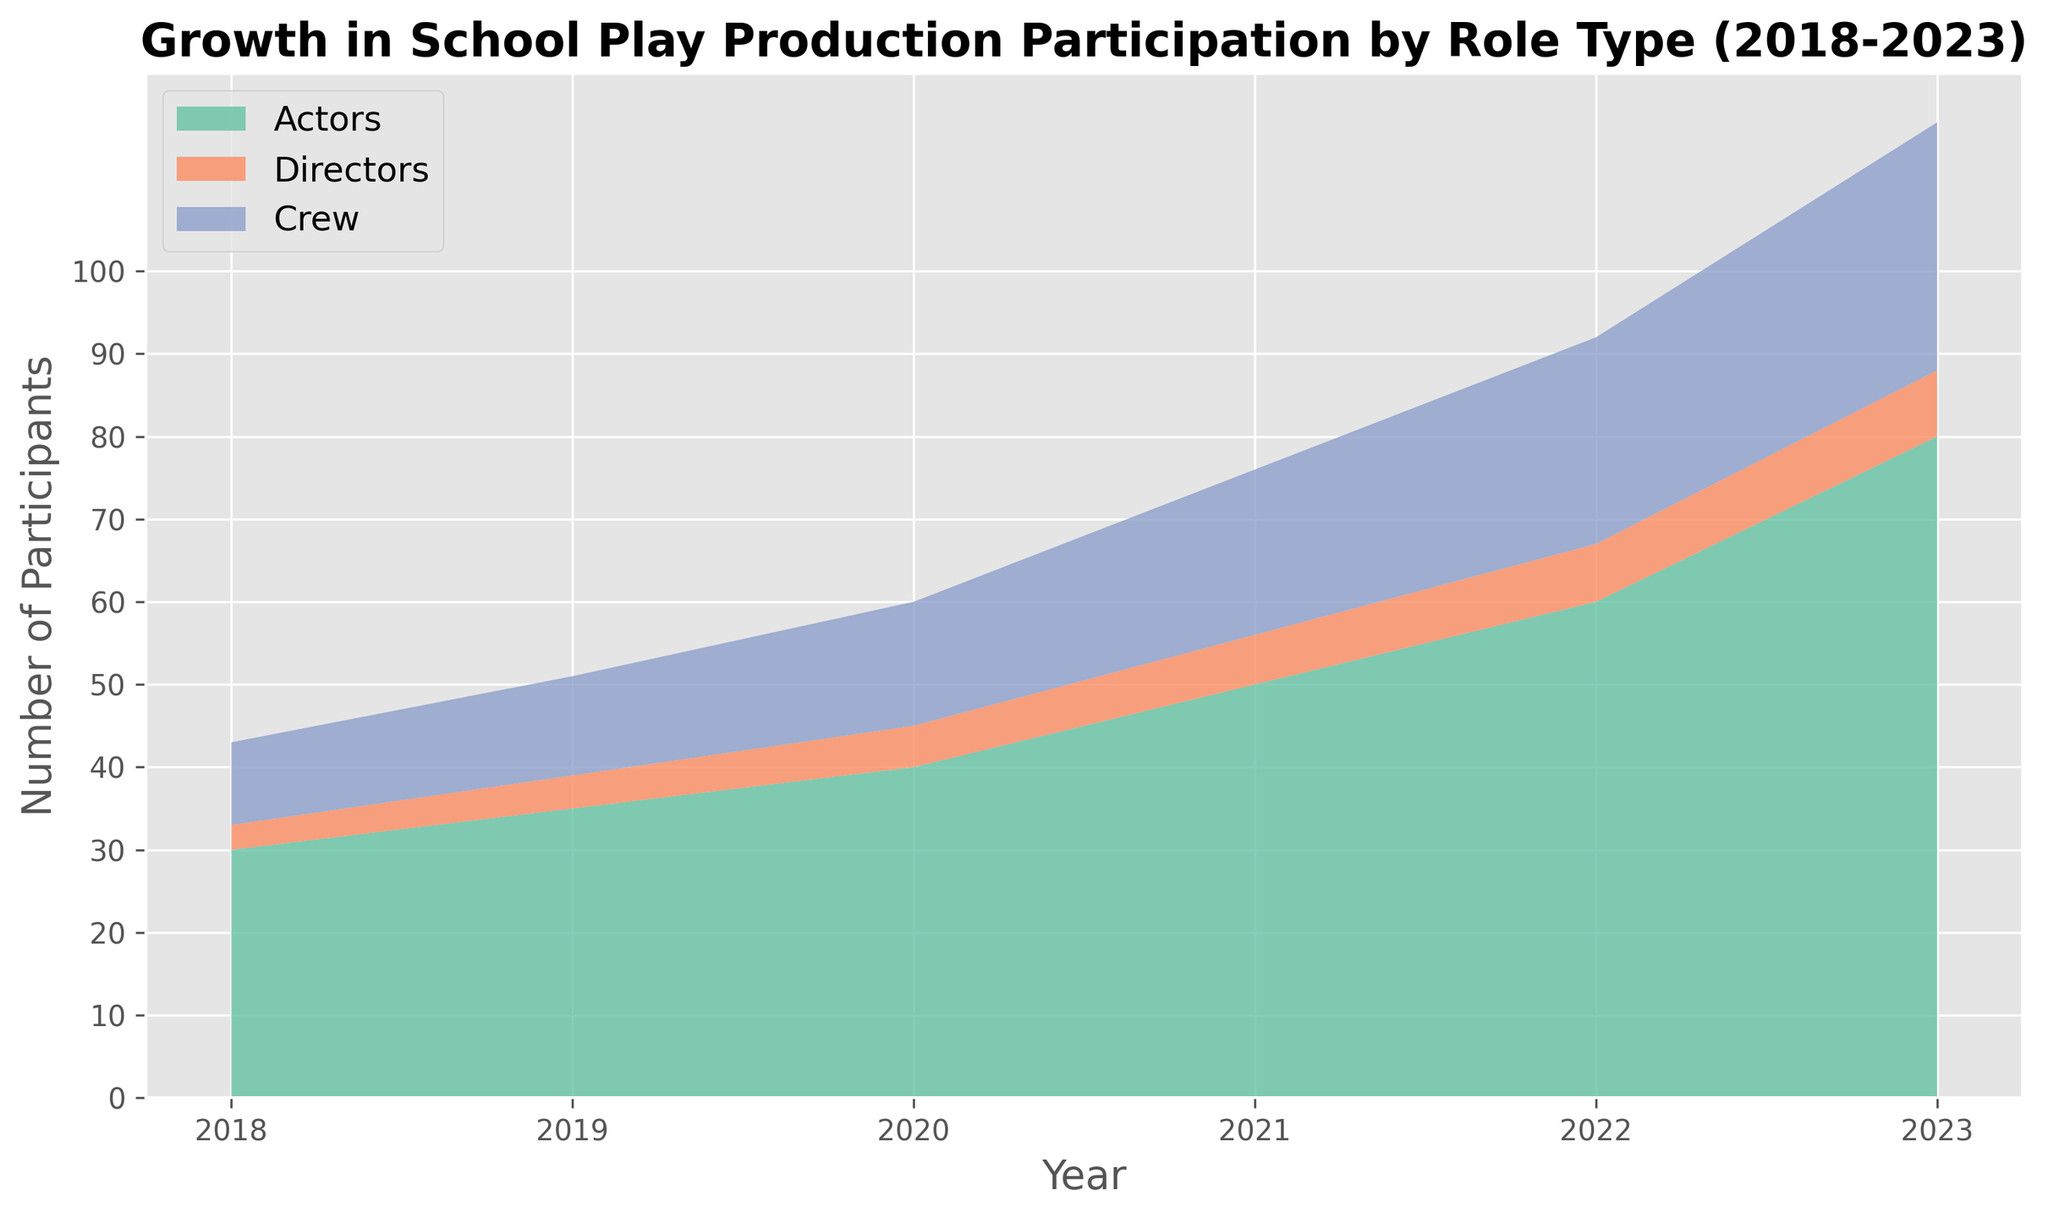Which role type had the highest participation in 2023? Observe the values for each role type in 2023. Actors had 80 participants, Directors had 8, and Crew had 30. Hence, Actors had the highest participation.
Answer: Actors In which year did the Crew first exceed 20 participants? Look at the Crew participation values over the years. In 2021, the Crew had 20 participants, and in 2022 it exceeded 20 participants by reaching 25.
Answer: 2022 What is the total number of participants in 2023 across all role types? Sum the number of participants for all roles in 2023. Actors had 80, Directors had 8, and Crew had 30. The total is 80 + 8 + 30 = 118.
Answer: 118 Which role type showed the greatest absolute increase in participants from 2022 to 2023? Calculate the increase between 2022 and 2023 for each role. Actors increased from 60 to 80 (an increase of 20), Directors from 7 to 8 (an increase of 1), and Crew from 25 to 30 (an increase of 5). The greatest increase is for Actors.
Answer: Actors What was the average number of Directors participating each year from 2018 to 2023? Average the number of Directors' participants over the six years. (3 + 4 + 5 + 6 + 7 + 8) / 6 = 33 / 6 = 5.5.
Answer: 5.5 How did the number of Actors change from the beginning to the end of the period? Compare the number of Actors in 2018 and 2023. There were 30 Actors in 2018 and 80 in 2023. Thus, the change is 80 - 30 = 50.
Answer: Increased by 50 In which year did the total participation (Actors, Directors, Crew) first exceed 70 participants? Calculate the total participation for each year and find the first year it exceeds 70. For 2021, the total is 50 (Actors) + 6 (Directors) + 20 (Crew) = 76, which exceeds 70.
Answer: 2021 Which role type consistently grew every year from 2018 to 2023 without any decrease? Check the participation values for each role type year by year. Both Actors and Crew consistently increased every year. Directors also grew but had smaller increments.
Answer: Actors, Directors, Crew What is the difference in the number of Crew participants between the years with the lowest and highest participation? Identify the lowest and highest values for Crew participants. The lowest is 10 in 2018, and the highest is 30 in 2023. The difference is 30 - 10 = 20.
Answer: 20 What percentage of the total participants in 2023 were Crew members? Calculate the percentage by dividing the number of Crew participants by the total number of participants in 2023 and multiplying by 100. (30 / 118) * 100 ≈ 25.42%.
Answer: 25.42% 